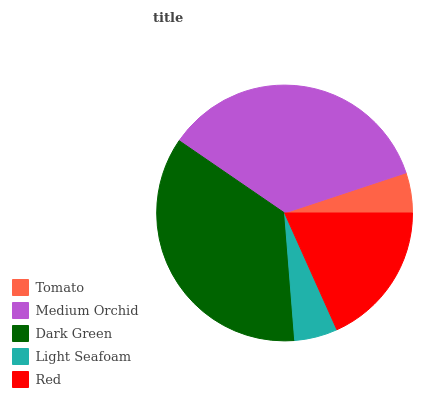Is Tomato the minimum?
Answer yes or no. Yes. Is Dark Green the maximum?
Answer yes or no. Yes. Is Medium Orchid the minimum?
Answer yes or no. No. Is Medium Orchid the maximum?
Answer yes or no. No. Is Medium Orchid greater than Tomato?
Answer yes or no. Yes. Is Tomato less than Medium Orchid?
Answer yes or no. Yes. Is Tomato greater than Medium Orchid?
Answer yes or no. No. Is Medium Orchid less than Tomato?
Answer yes or no. No. Is Red the high median?
Answer yes or no. Yes. Is Red the low median?
Answer yes or no. Yes. Is Light Seafoam the high median?
Answer yes or no. No. Is Dark Green the low median?
Answer yes or no. No. 